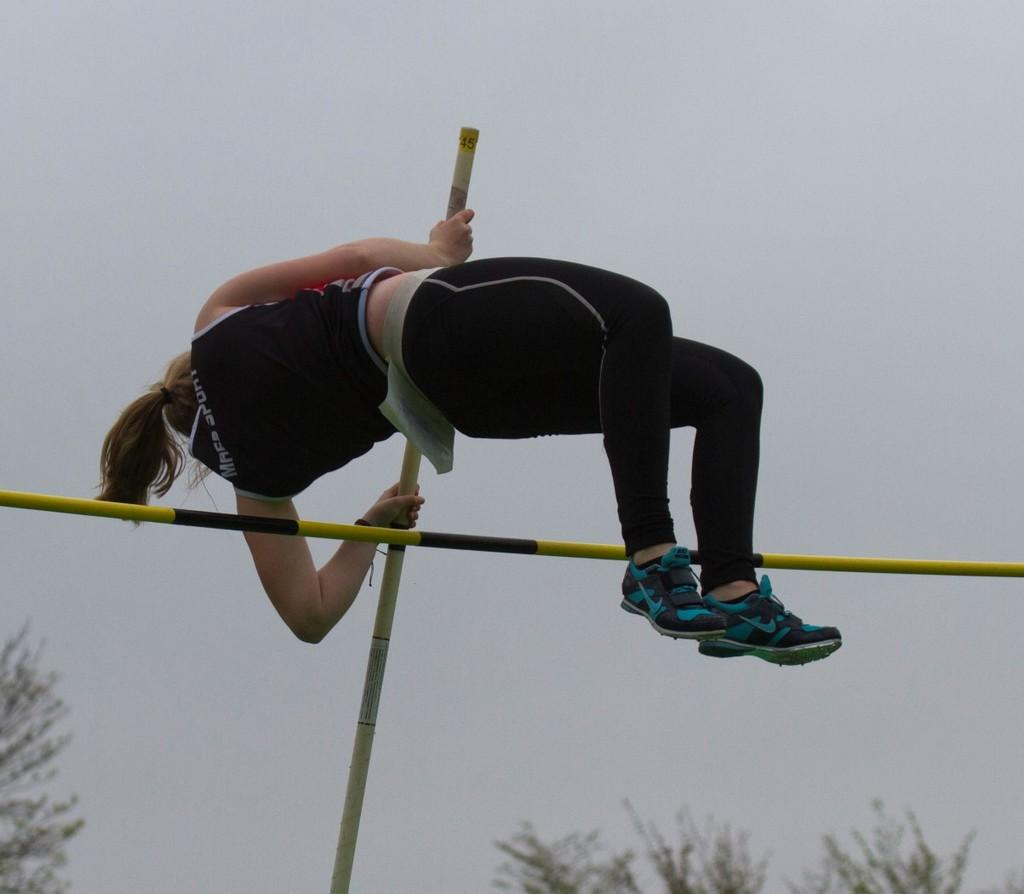Who is the main subject in the image? There is a woman in the image. What is the woman doing in the image? The woman is jumping. What can be seen in the background of the image? There are trees and the sky visible in the background of the image. What type of horn is the woman holding in the image? There is no horn present in the image; the woman is simply jumping. 